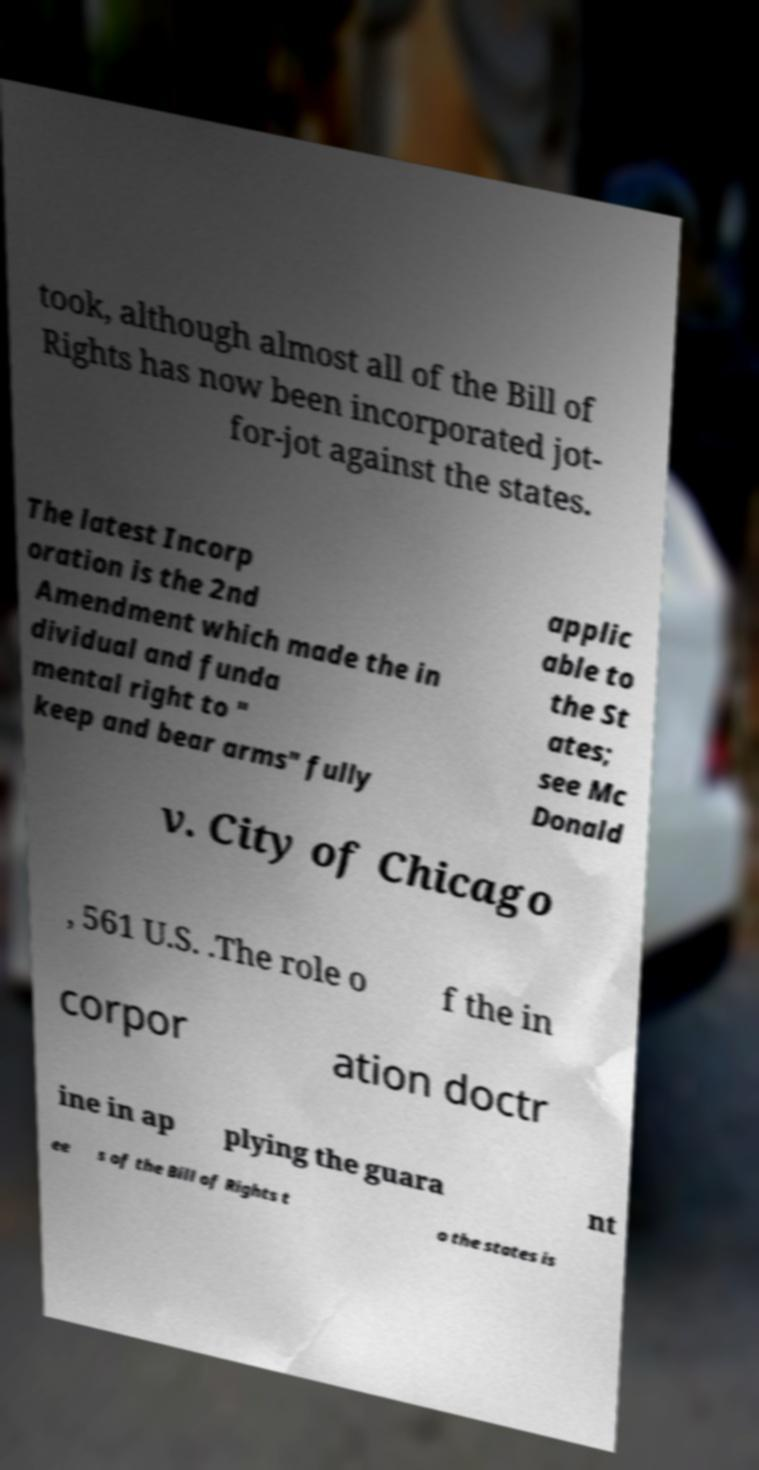What messages or text are displayed in this image? I need them in a readable, typed format. took, although almost all of the Bill of Rights has now been incorporated jot- for-jot against the states. The latest Incorp oration is the 2nd Amendment which made the in dividual and funda mental right to " keep and bear arms" fully applic able to the St ates; see Mc Donald v. City of Chicago , 561 U.S. .The role o f the in corpor ation doctr ine in ap plying the guara nt ee s of the Bill of Rights t o the states is 